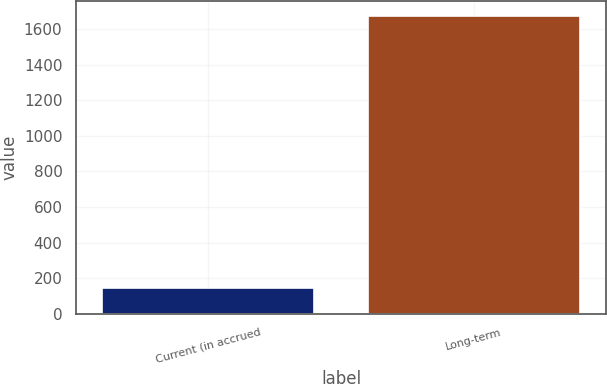Convert chart. <chart><loc_0><loc_0><loc_500><loc_500><bar_chart><fcel>Current (in accrued<fcel>Long-term<nl><fcel>147<fcel>1675<nl></chart> 